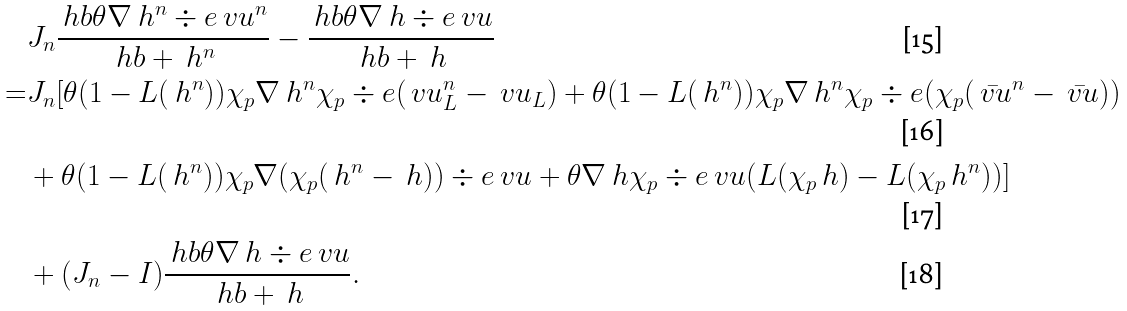<formula> <loc_0><loc_0><loc_500><loc_500>& J _ { n } \frac { \ h b \theta \nabla \ h ^ { n } \div e \ v u ^ { n } } { \ h b + \ h ^ { n } } - \frac { \ h b \theta \nabla \ h \div e \ v u } { \ h b + \ h } \\ = & J _ { n } [ \theta ( 1 - L ( \ h ^ { n } ) ) \chi _ { p } \nabla \ h ^ { n } \chi _ { p } \div e ( \ v u _ { L } ^ { n } - \ v u _ { L } ) + \theta ( 1 - L ( \ h ^ { n } ) ) \chi _ { p } \nabla \ h ^ { n } \chi _ { p } \div e ( \chi _ { p } ( \bar { \ v u } ^ { n } - \bar { \ v u } ) ) \\ & + \theta ( 1 - L ( \ h ^ { n } ) ) \chi _ { p } \nabla ( \chi _ { p } ( \ h ^ { n } - \ h ) ) \div e \ v u + \theta \nabla \ h \chi _ { p } \div e \ v u ( L ( \chi _ { p } \ h ) - L ( \chi _ { p } \ h ^ { n } ) ) ] \\ & + ( J _ { n } - I ) \frac { \ h b \theta \nabla \ h \div e \ v u } { \ h b + \ h } .</formula> 